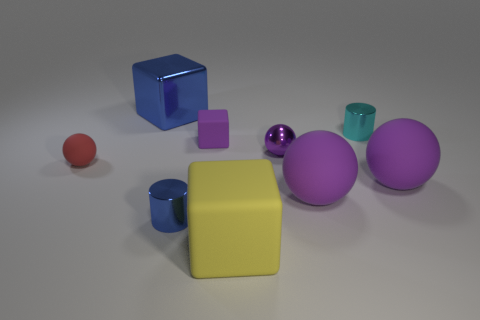Subtract all red cylinders. How many purple spheres are left? 3 Subtract all balls. How many objects are left? 5 Subtract 0 brown cubes. How many objects are left? 9 Subtract all spheres. Subtract all small metal cylinders. How many objects are left? 3 Add 3 metal things. How many metal things are left? 7 Add 7 shiny spheres. How many shiny spheres exist? 8 